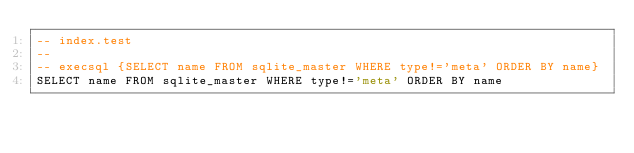Convert code to text. <code><loc_0><loc_0><loc_500><loc_500><_SQL_>-- index.test
-- 
-- execsql {SELECT name FROM sqlite_master WHERE type!='meta' ORDER BY name}
SELECT name FROM sqlite_master WHERE type!='meta' ORDER BY name</code> 